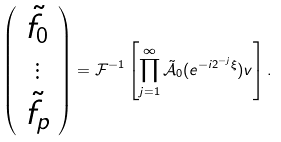<formula> <loc_0><loc_0><loc_500><loc_500>\left ( \begin{array} { c } \tilde { f } _ { 0 } \\ \vdots \\ \tilde { f } _ { p } \end{array} \right ) = \mathcal { F } ^ { - 1 } \left [ \prod _ { j = 1 } ^ { \infty } \tilde { \mathcal { A } } _ { 0 } ( e ^ { - i 2 ^ { - j } \xi } ) v \right ] .</formula> 